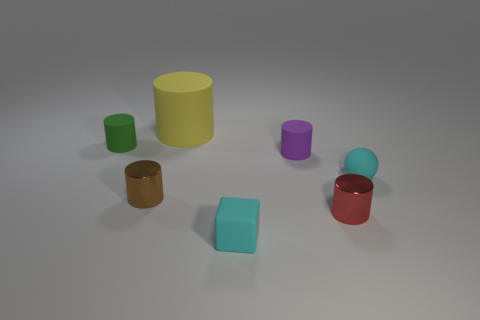Add 2 large red rubber cubes. How many objects exist? 9 Subtract all large yellow matte cylinders. How many cylinders are left? 4 Subtract all brown cylinders. How many cylinders are left? 4 Subtract all cylinders. How many objects are left? 2 Subtract all purple spheres. Subtract all cyan cylinders. How many spheres are left? 1 Subtract all big matte cylinders. Subtract all green things. How many objects are left? 5 Add 5 tiny cyan objects. How many tiny cyan objects are left? 7 Add 4 small red cylinders. How many small red cylinders exist? 5 Subtract 1 cyan blocks. How many objects are left? 6 